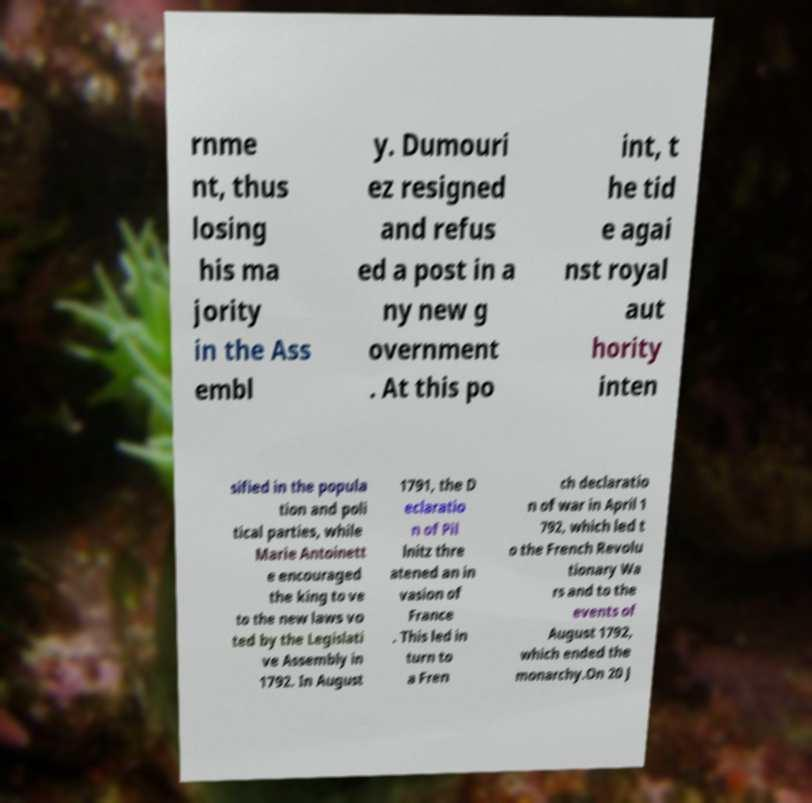Could you assist in decoding the text presented in this image and type it out clearly? rnme nt, thus losing his ma jority in the Ass embl y. Dumouri ez resigned and refus ed a post in a ny new g overnment . At this po int, t he tid e agai nst royal aut hority inten sified in the popula tion and poli tical parties, while Marie Antoinett e encouraged the king to ve to the new laws vo ted by the Legislati ve Assembly in 1792. In August 1791, the D eclaratio n of Pil lnitz thre atened an in vasion of France . This led in turn to a Fren ch declaratio n of war in April 1 792, which led t o the French Revolu tionary Wa rs and to the events of August 1792, which ended the monarchy.On 20 J 